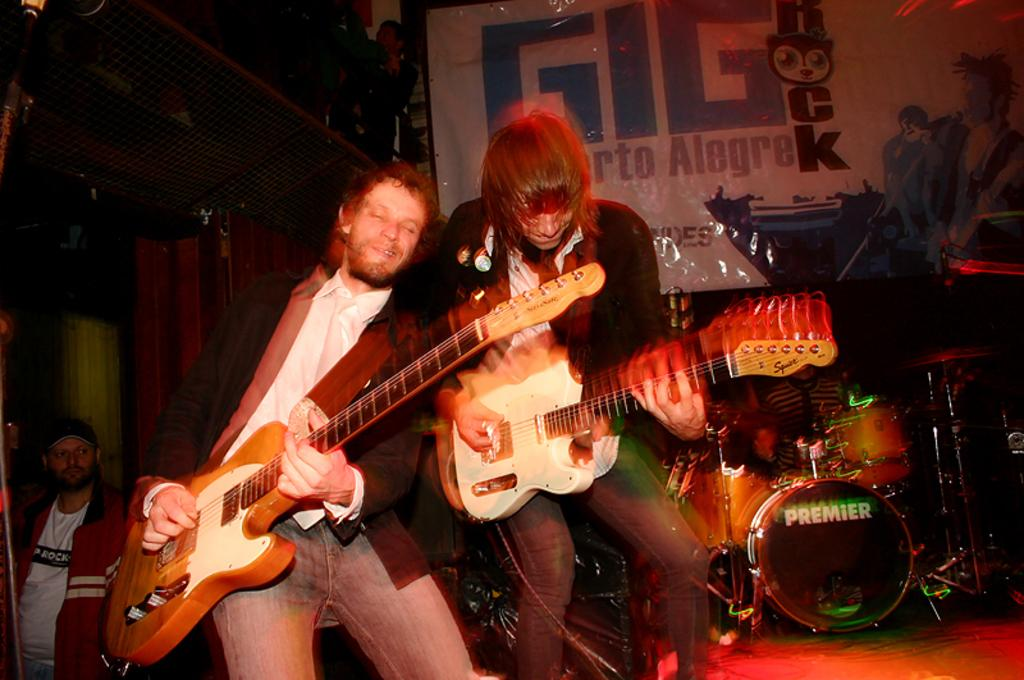How many people are in the image? There are two men in the image. What are the men doing in the image? The men are playing guitar. Can you describe the background of the image? There are people visible in the background, and there are musical instruments present as well. How many yams are being used as a musical instrument in the image? There are no yams present in the image, and they are not being used as a musical instrument. 